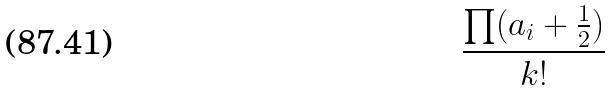<formula> <loc_0><loc_0><loc_500><loc_500>\frac { \prod ( a _ { i } + \frac { 1 } { 2 } ) } { k ! }</formula> 